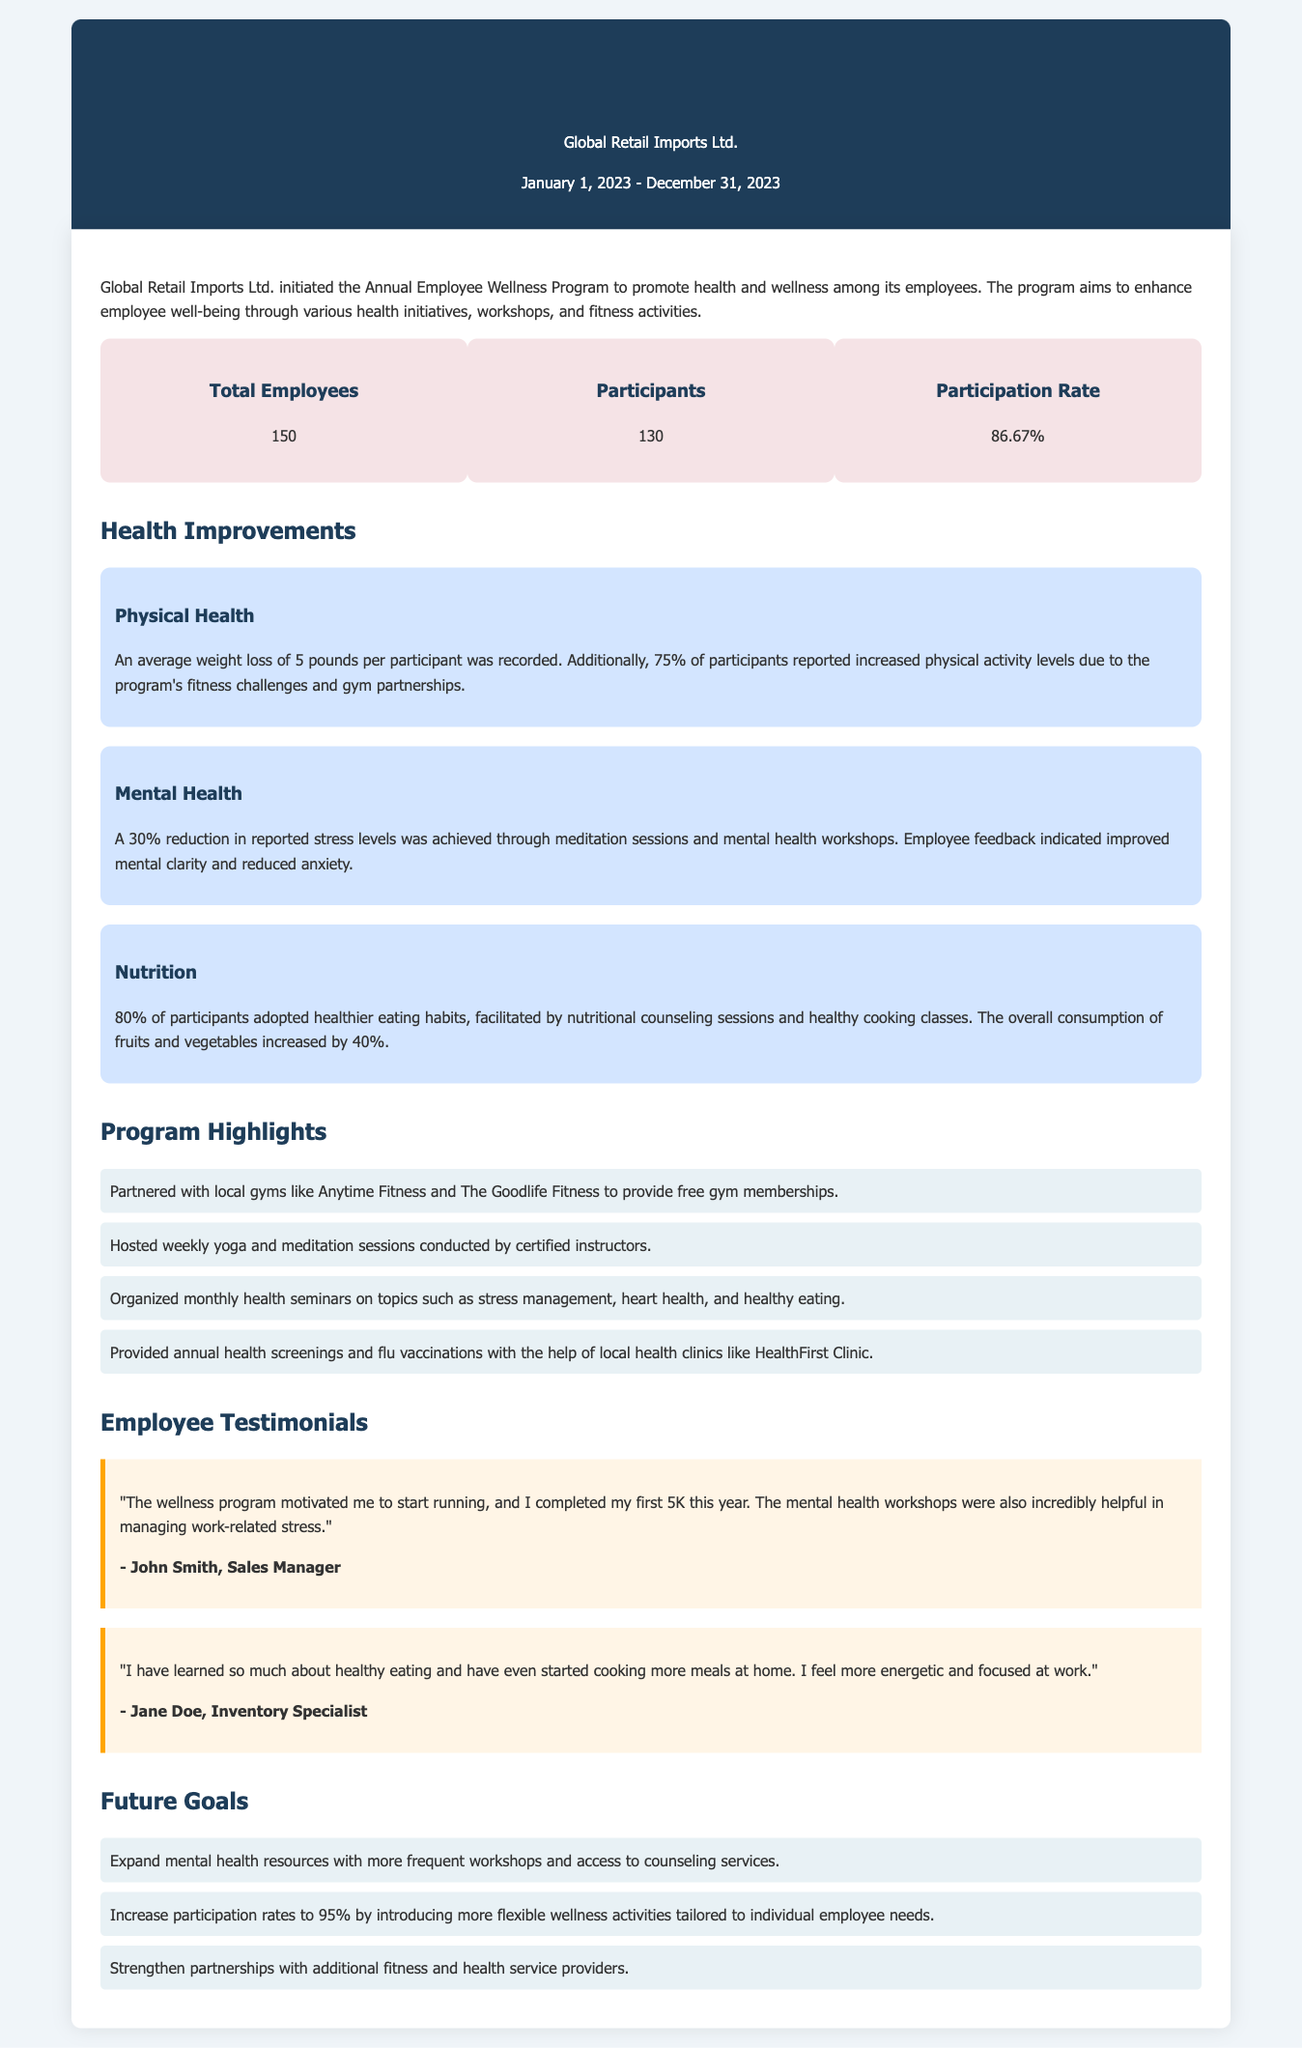What was the total employee count? The document states that there were 150 total employees at Global Retail Imports Ltd.
Answer: 150 How many employees participated in the wellness program? The document mentions that 130 employees participated in the wellness program.
Answer: 130 What percentage of employees participated in the program? The participation rate is calculated from the number of participants and total employees, which is 86.67%.
Answer: 86.67% What was the average weight loss among participants? The document indicates that there was an average weight loss of 5 pounds per participant.
Answer: 5 pounds What percentage of participants reported increased physical activity? According to the document, 75% of participants reported increased physical activity levels.
Answer: 75% Which health improvements showed a 30% reduction? The document specifies a 30% reduction in reported stress levels for mental health improvements.
Answer: Stress levels What is one future goal of the wellness program? The document states that one goal is to expand mental health resources with more workshops.
Answer: Expand mental health resources Which local gym partnered with the wellness program? The document mentions Anytime Fitness as a partnered local gym.
Answer: Anytime Fitness What percentage of participants adopted healthier eating habits? The document notes that 80% of participants adopted healthier eating habits.
Answer: 80% 